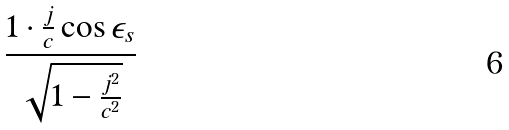<formula> <loc_0><loc_0><loc_500><loc_500>\frac { 1 \cdot \frac { j } { c } \cos \epsilon _ { s } } { \sqrt { 1 - \frac { j ^ { 2 } } { c ^ { 2 } } } }</formula> 